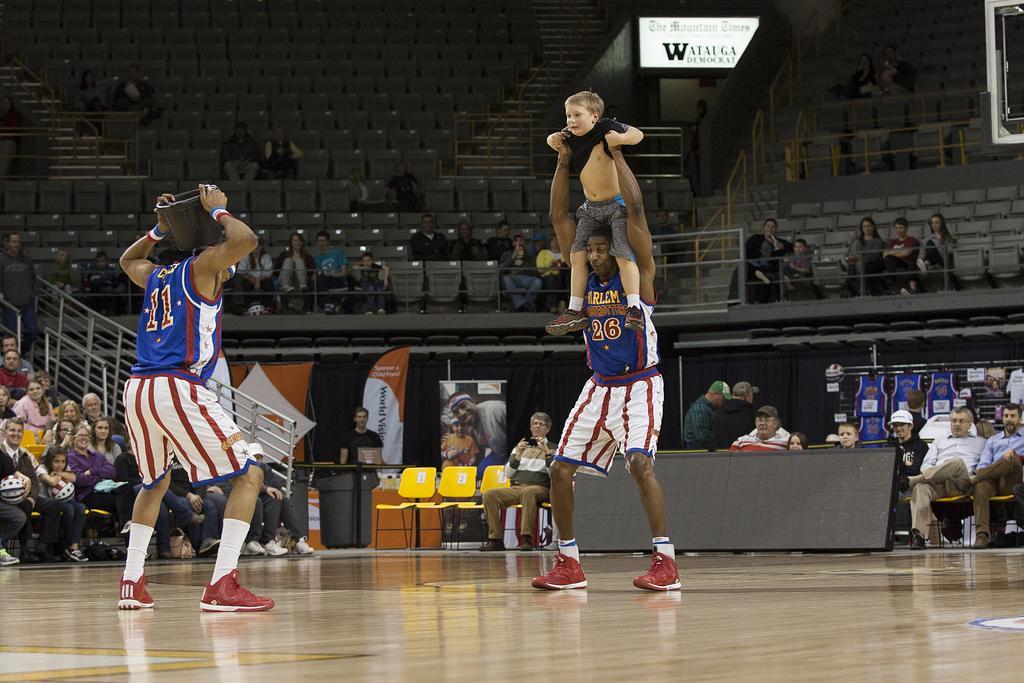How would you summarize this image in a sentence or two? This picture might be taken in a stadium, in this image in the foreground there are two persons standing and one person is holding one boy and another person is holding some pot. In the background there are a group of people sitting, and there is a railing and some chairs and boards. On the boards there is some text, at the bottom there is floor. 